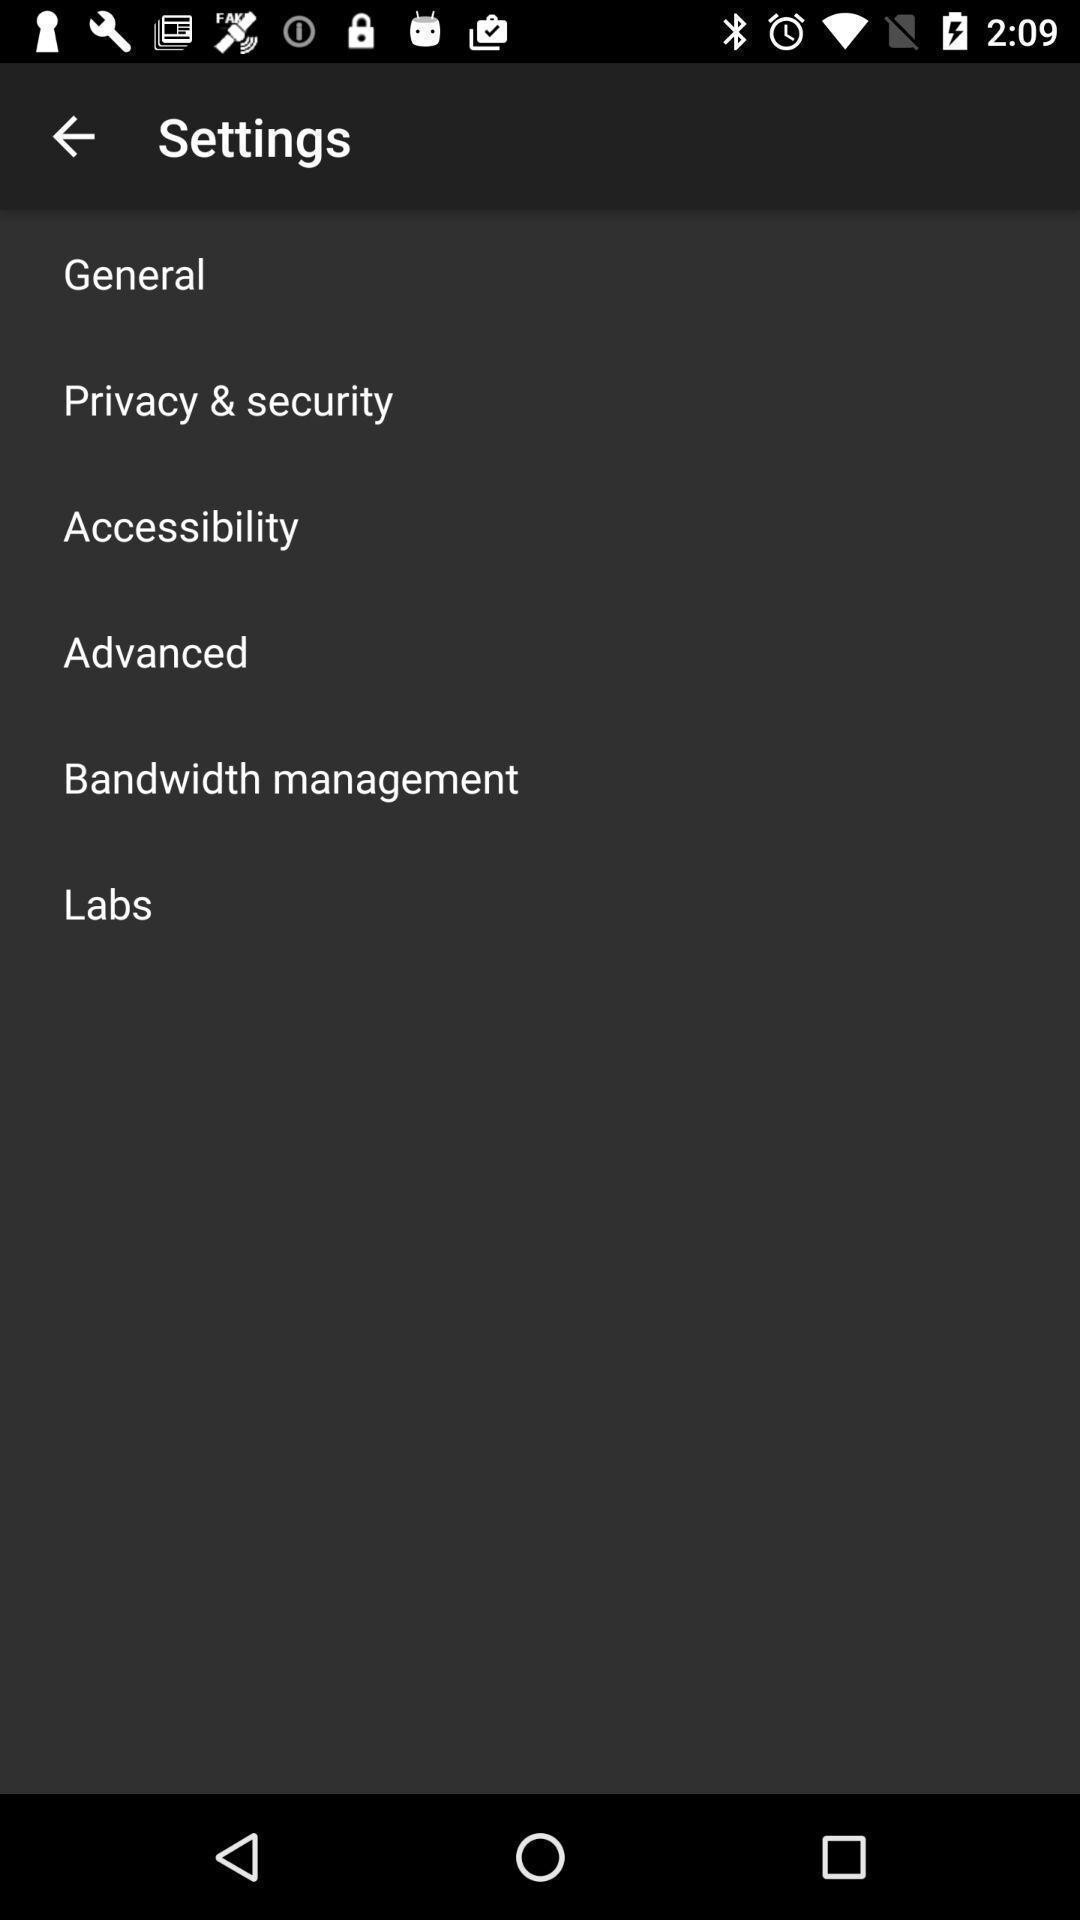Provide a textual representation of this image. Screen showing settings page. 